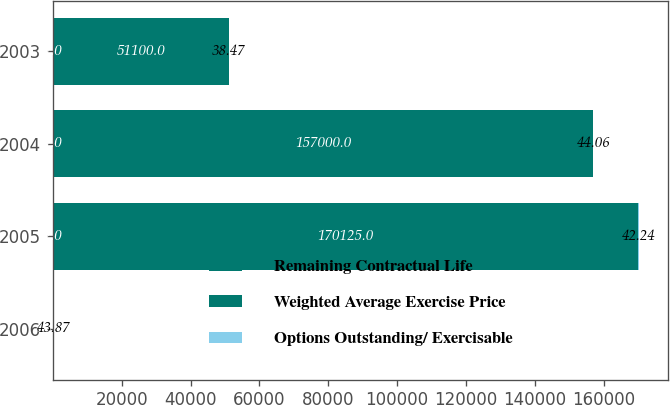Convert chart. <chart><loc_0><loc_0><loc_500><loc_500><stacked_bar_chart><ecel><fcel>2006<fcel>2005<fcel>2004<fcel>2003<nl><fcel>Remaining Contractual Life<fcel>3<fcel>2<fcel>1<fcel>1<nl><fcel>Weighted Average Exercise Price<fcel>42.24<fcel>170125<fcel>157000<fcel>51100<nl><fcel>Options Outstanding/ Exercisable<fcel>43.87<fcel>42.24<fcel>44.06<fcel>38.47<nl></chart> 